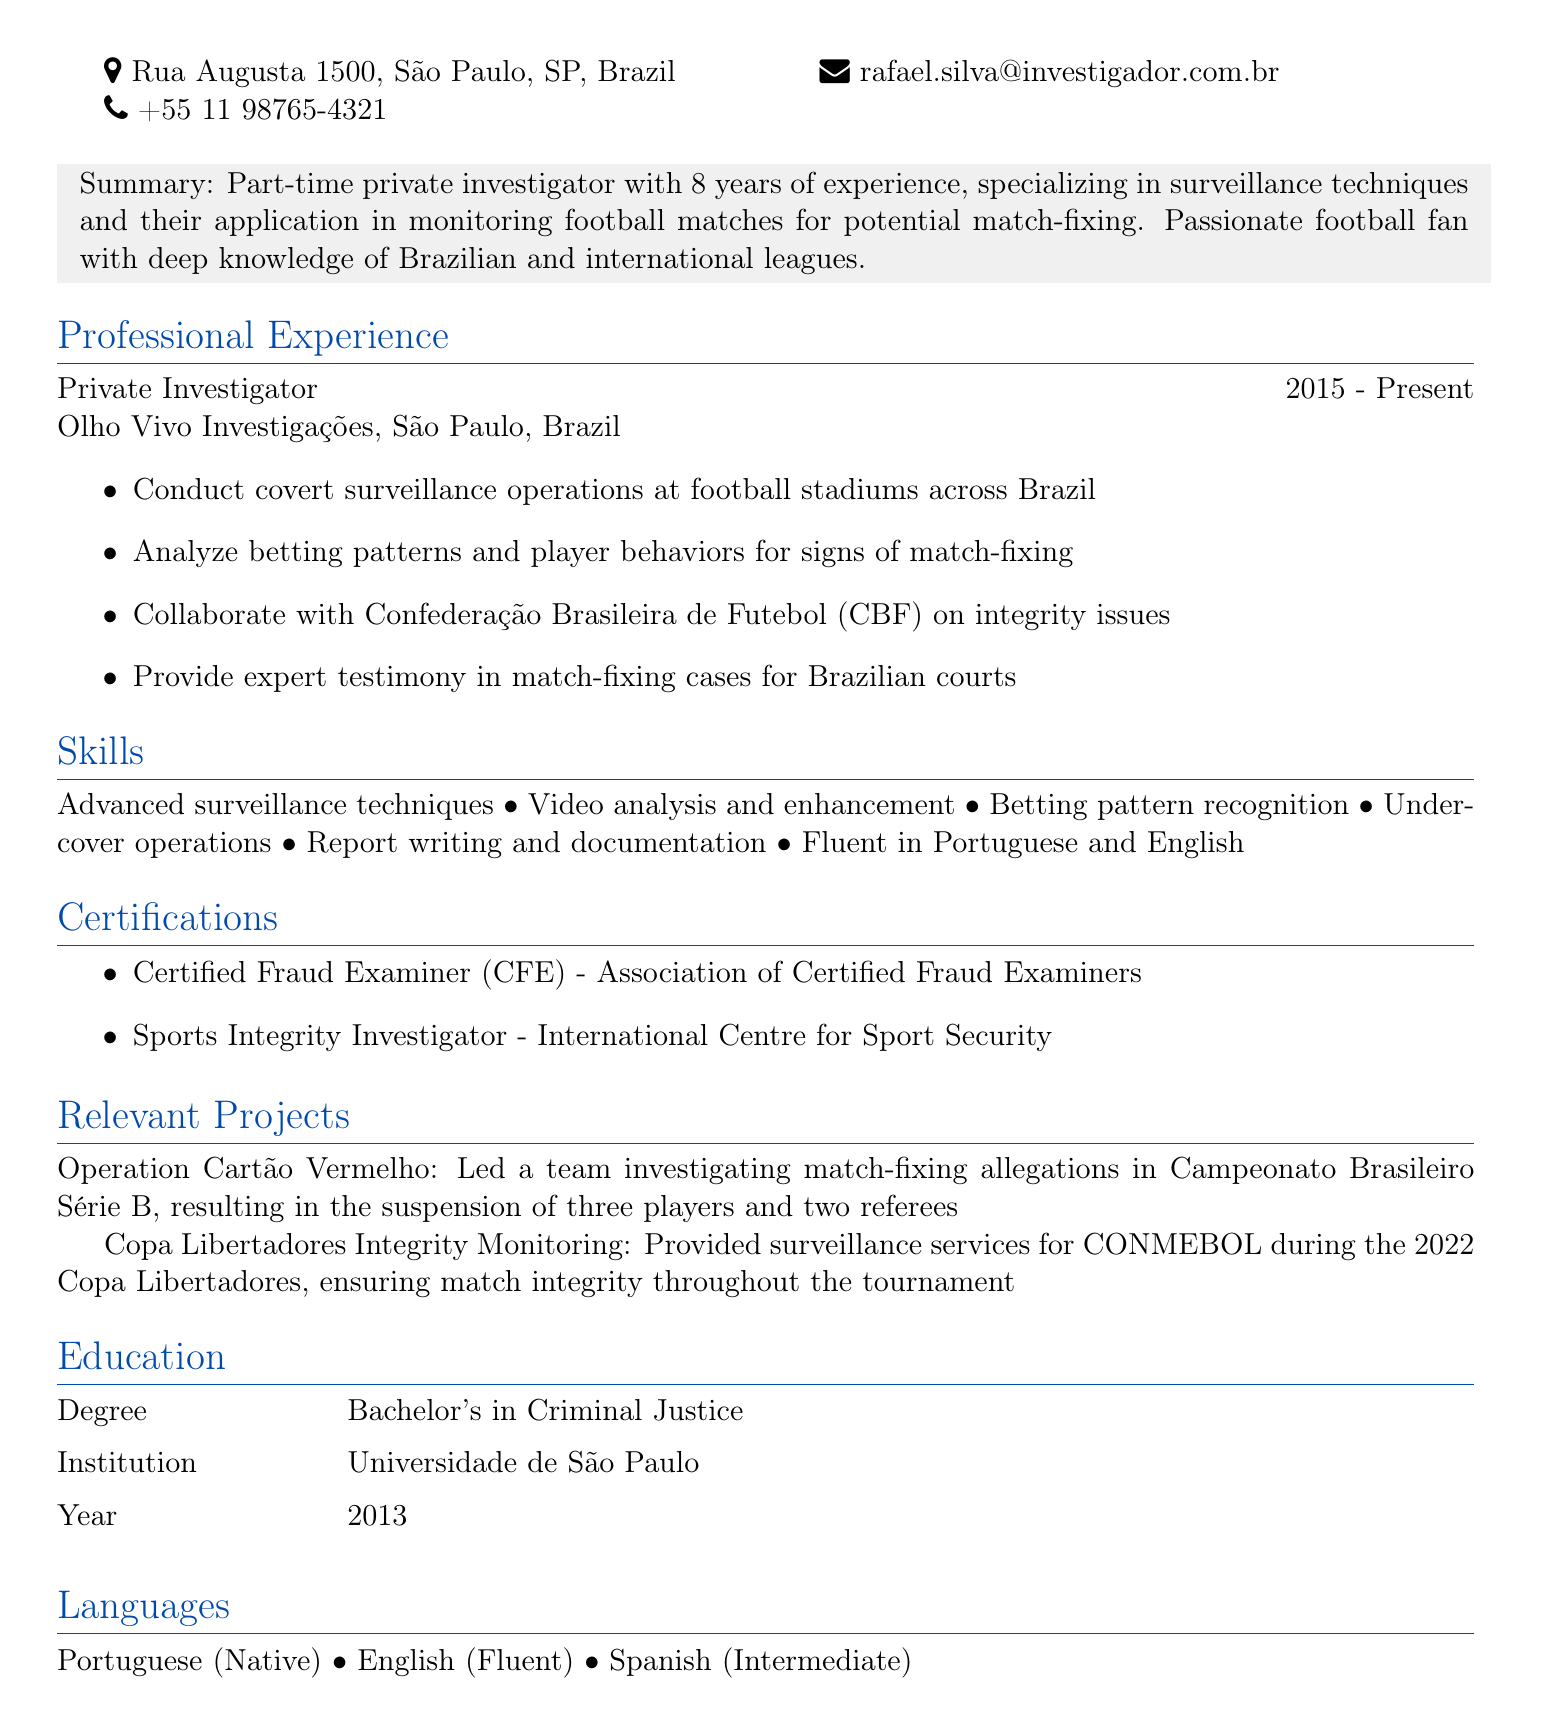What is the name of the investigator? The name is provided in the personal information section of the CV.
Answer: Rafael Silva What is the email address of Rafael Silva? The email address is listed in the personal information section of the CV.
Answer: rafael.silva@investigador.com.br How many years of experience does Rafael Silva have? The summary section of the CV states his years of experience directly.
Answer: 8 years Which certification does Rafael Silva hold associated with fraud examination? The certifications section lists this information specifically.
Answer: Certified Fraud Examiner (CFE) What role does Rafael Silva currently hold? The professional experience section indicates his current title.
Answer: Private Investigator In what year did Rafael Silva complete his Bachelor's degree? This information is detailed in the education section of the CV.
Answer: 2013 Which football organization does Rafael Silva collaborate with on integrity issues? The professional experience section lists this information explicitly.
Answer: Confederação Brasileira de Futebol (CBF) What significant project involved three players and two referees? A relevant project section highlights a specific investigation that led to these suspensions.
Answer: Operation Cartão Vermelho What languages is Rafael Silva fluent in? The languages section specifically names the languages he speaks.
Answer: Portuguese and English 